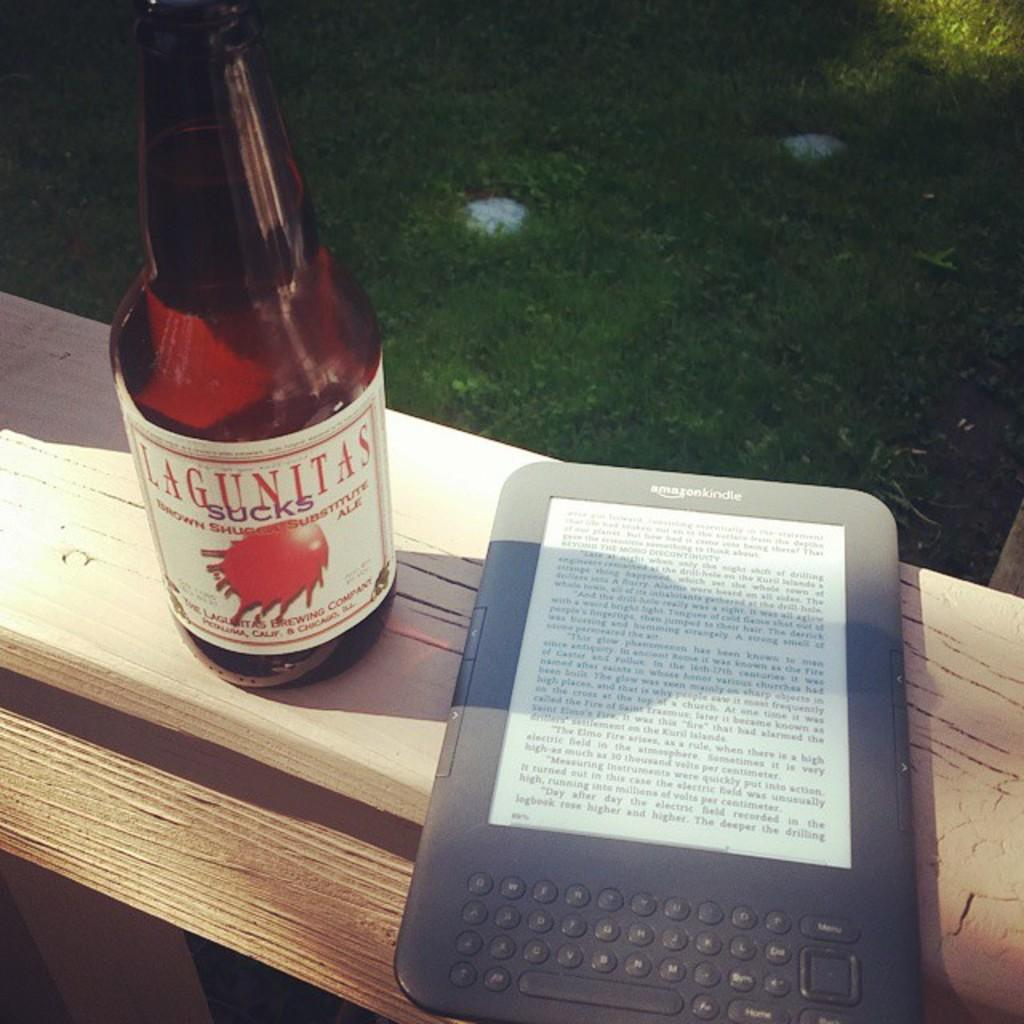<image>
Summarize the visual content of the image. A bottle of Lagunitas sitting next to an e-book. 